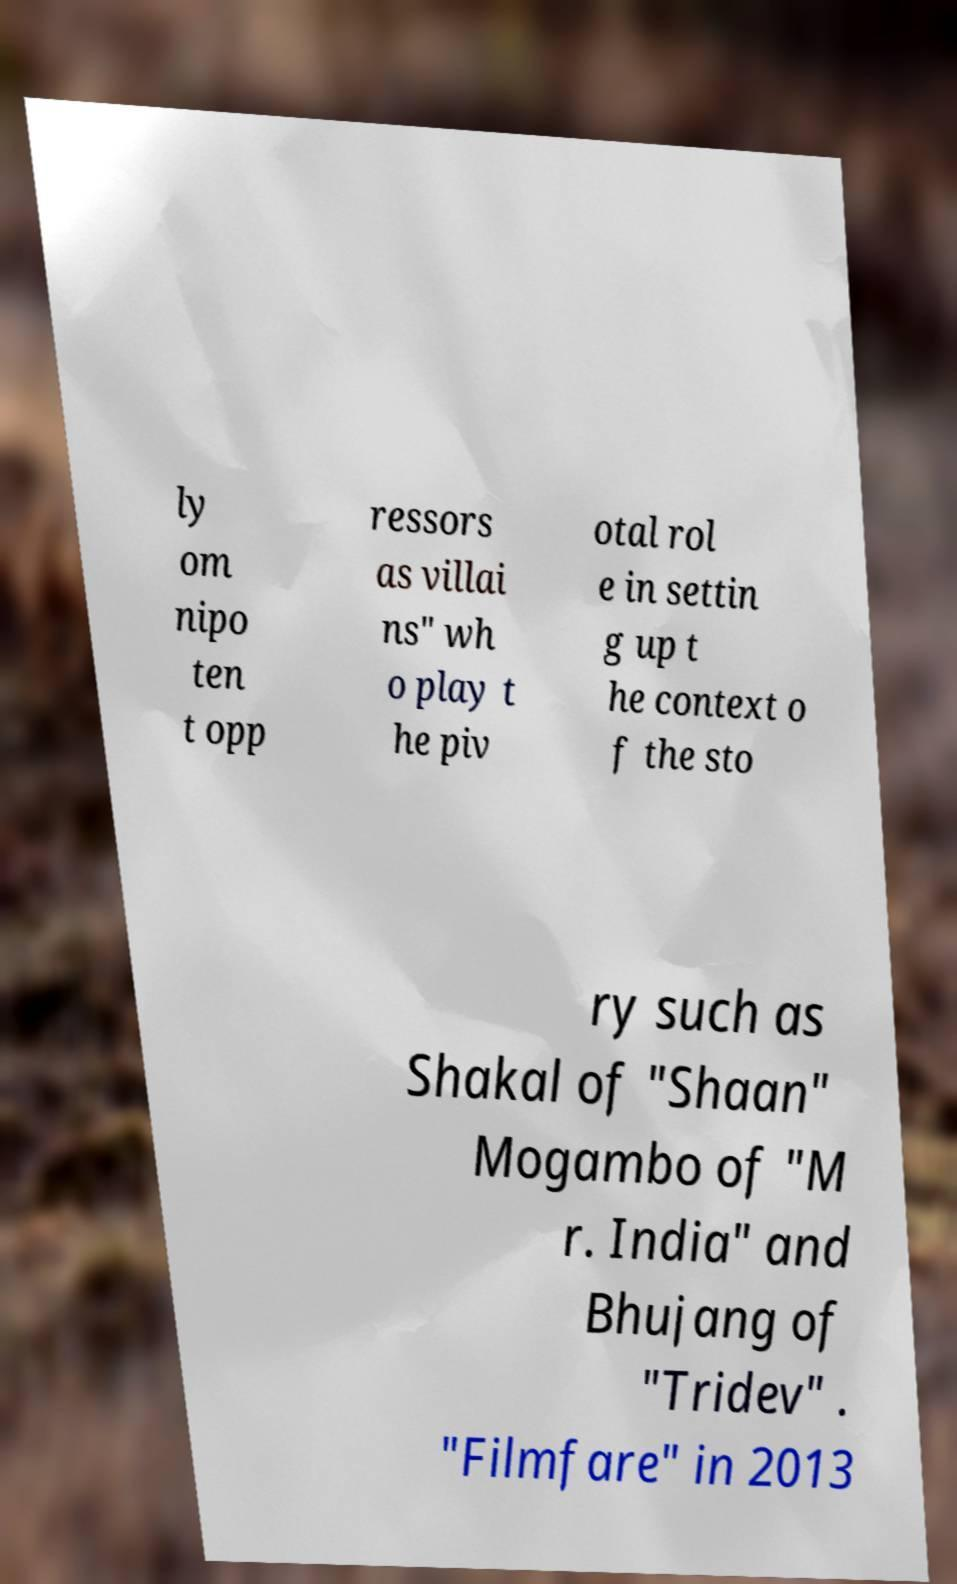Could you extract and type out the text from this image? ly om nipo ten t opp ressors as villai ns" wh o play t he piv otal rol e in settin g up t he context o f the sto ry such as Shakal of "Shaan" Mogambo of "M r. India" and Bhujang of "Tridev" . "Filmfare" in 2013 